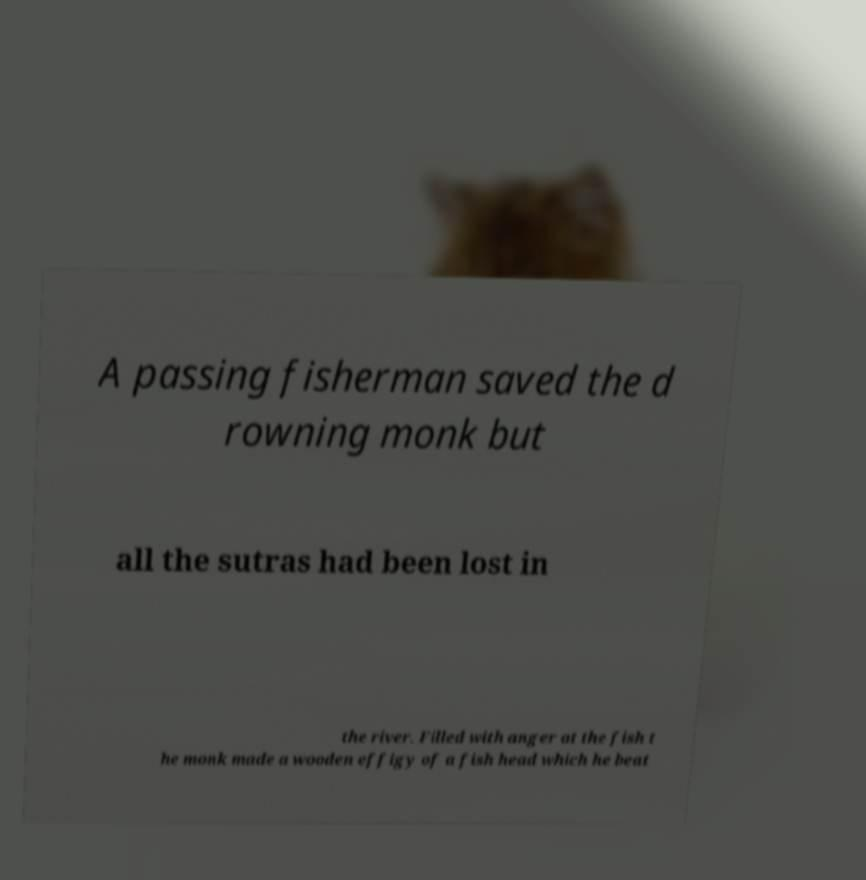For documentation purposes, I need the text within this image transcribed. Could you provide that? A passing fisherman saved the d rowning monk but all the sutras had been lost in the river. Filled with anger at the fish t he monk made a wooden effigy of a fish head which he beat 